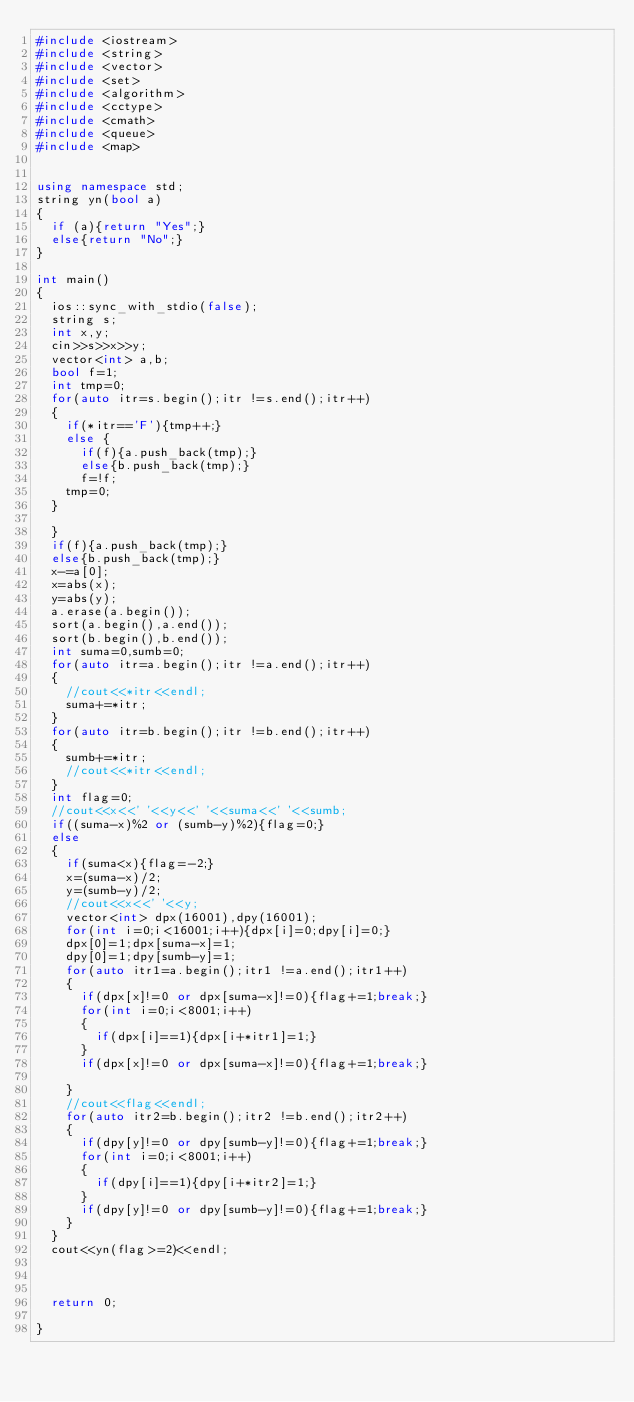Convert code to text. <code><loc_0><loc_0><loc_500><loc_500><_C++_>#include <iostream>
#include <string>
#include <vector>
#include <set>
#include <algorithm>
#include <cctype>
#include <cmath>
#include <queue>
#include <map>


using namespace std;
string yn(bool a)
{
  if (a){return "Yes";}
  else{return "No";}
}

int main()
{
  ios::sync_with_stdio(false);
  string s;
  int x,y;
  cin>>s>>x>>y;
  vector<int> a,b;
  bool f=1;
  int tmp=0;
  for(auto itr=s.begin();itr !=s.end();itr++)
  {
    if(*itr=='F'){tmp++;}
    else {
      if(f){a.push_back(tmp);}
      else{b.push_back(tmp);}
      f=!f;
    tmp=0;
  }

  }
  if(f){a.push_back(tmp);}
  else{b.push_back(tmp);}
  x-=a[0];
  x=abs(x);
  y=abs(y);
  a.erase(a.begin());
  sort(a.begin(),a.end());
  sort(b.begin(),b.end());
  int suma=0,sumb=0;
  for(auto itr=a.begin();itr !=a.end();itr++)
  {
    //cout<<*itr<<endl;
    suma+=*itr;
  }
  for(auto itr=b.begin();itr !=b.end();itr++)
  {
    sumb+=*itr;
    //cout<<*itr<<endl;
  }
  int flag=0;
  //cout<<x<<' '<<y<<' '<<suma<<' '<<sumb;
  if((suma-x)%2 or (sumb-y)%2){flag=0;}
  else
  {
    if(suma<x){flag=-2;}
    x=(suma-x)/2;
    y=(sumb-y)/2;
    //cout<<x<<' '<<y;
    vector<int> dpx(16001),dpy(16001);
    for(int i=0;i<16001;i++){dpx[i]=0;dpy[i]=0;}
    dpx[0]=1;dpx[suma-x]=1;
    dpy[0]=1;dpy[sumb-y]=1;
    for(auto itr1=a.begin();itr1 !=a.end();itr1++)
    {
      if(dpx[x]!=0 or dpx[suma-x]!=0){flag+=1;break;}
      for(int i=0;i<8001;i++)
      {
        if(dpx[i]==1){dpx[i+*itr1]=1;}
      }
      if(dpx[x]!=0 or dpx[suma-x]!=0){flag+=1;break;}

    }
    //cout<<flag<<endl;
    for(auto itr2=b.begin();itr2 !=b.end();itr2++)
    {
      if(dpy[y]!=0 or dpy[sumb-y]!=0){flag+=1;break;}
      for(int i=0;i<8001;i++)
      {
        if(dpy[i]==1){dpy[i+*itr2]=1;}
      }
      if(dpy[y]!=0 or dpy[sumb-y]!=0){flag+=1;break;}
    }
  }
  cout<<yn(flag>=2)<<endl;



  return 0;

}</code> 